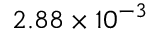<formula> <loc_0><loc_0><loc_500><loc_500>2 . 8 8 \times 1 0 ^ { - 3 }</formula> 